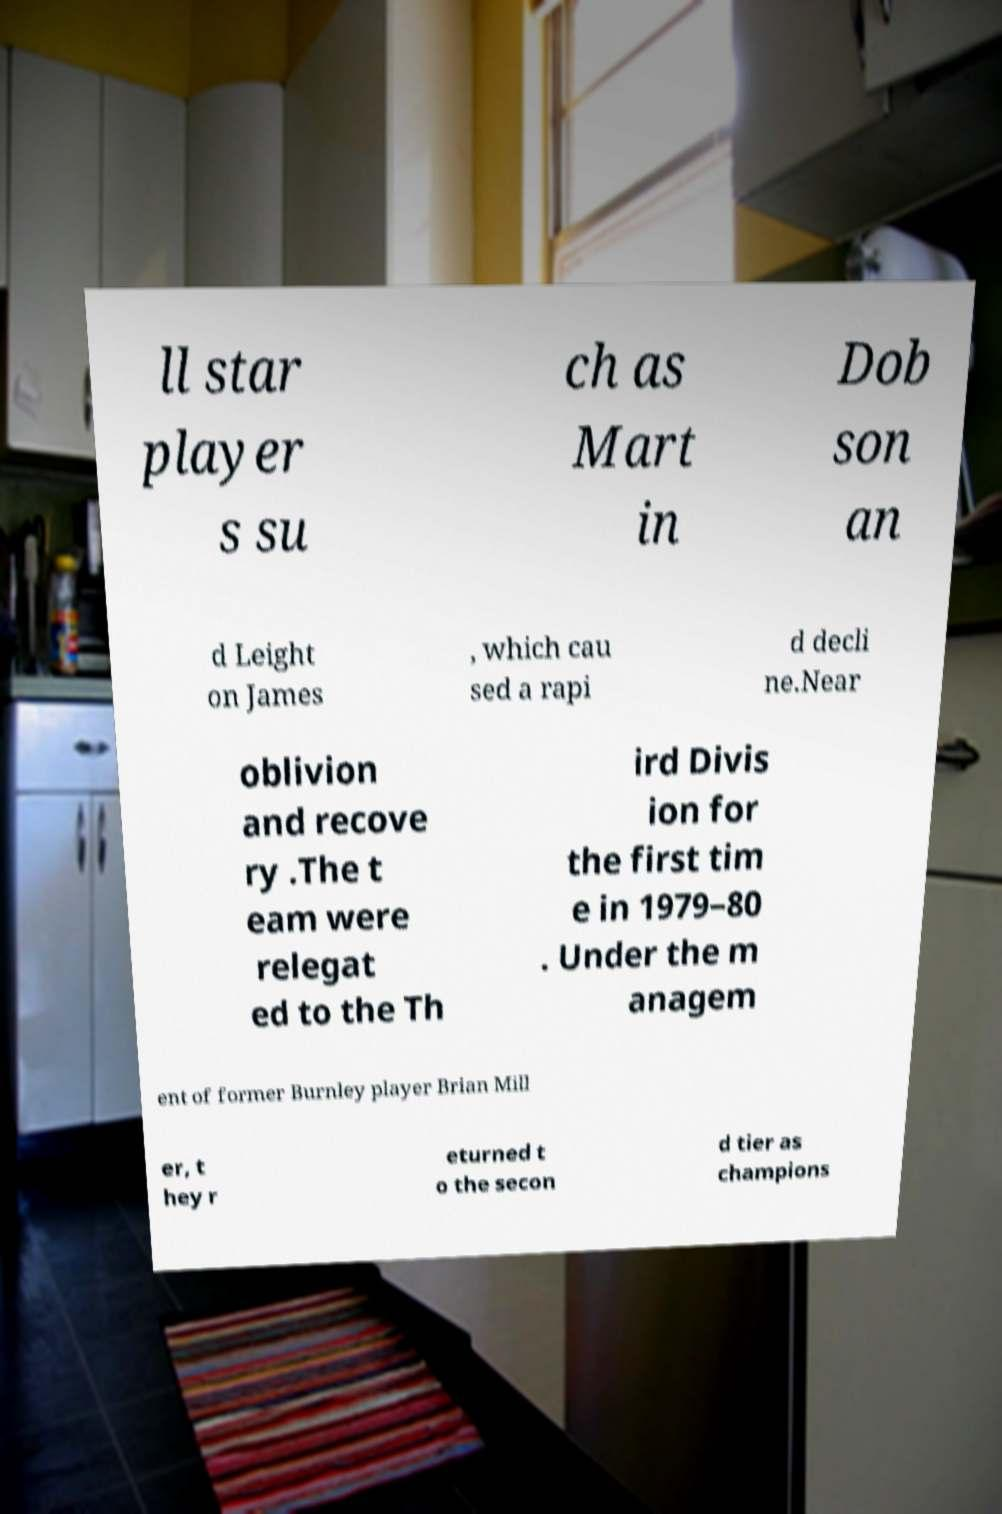Could you assist in decoding the text presented in this image and type it out clearly? ll star player s su ch as Mart in Dob son an d Leight on James , which cau sed a rapi d decli ne.Near oblivion and recove ry .The t eam were relegat ed to the Th ird Divis ion for the first tim e in 1979–80 . Under the m anagem ent of former Burnley player Brian Mill er, t hey r eturned t o the secon d tier as champions 